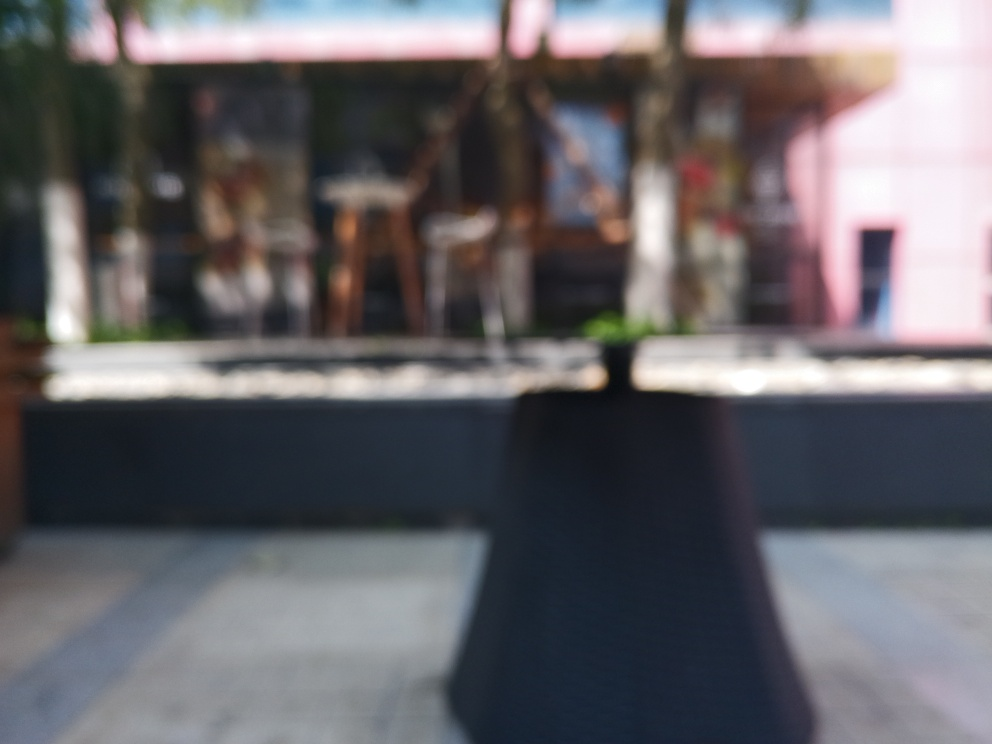What might be the context or setting of this image, despite the blur? Even with the blurred quality, the context suggests an outdoor setting, possibly a patio or café area. The presence of furniture that resembles tables and chairs implies a location designed for sitting and likely dining or socializing, while the streaks of light and sporadic patches of blue hint at this being taken during daylight hours. 